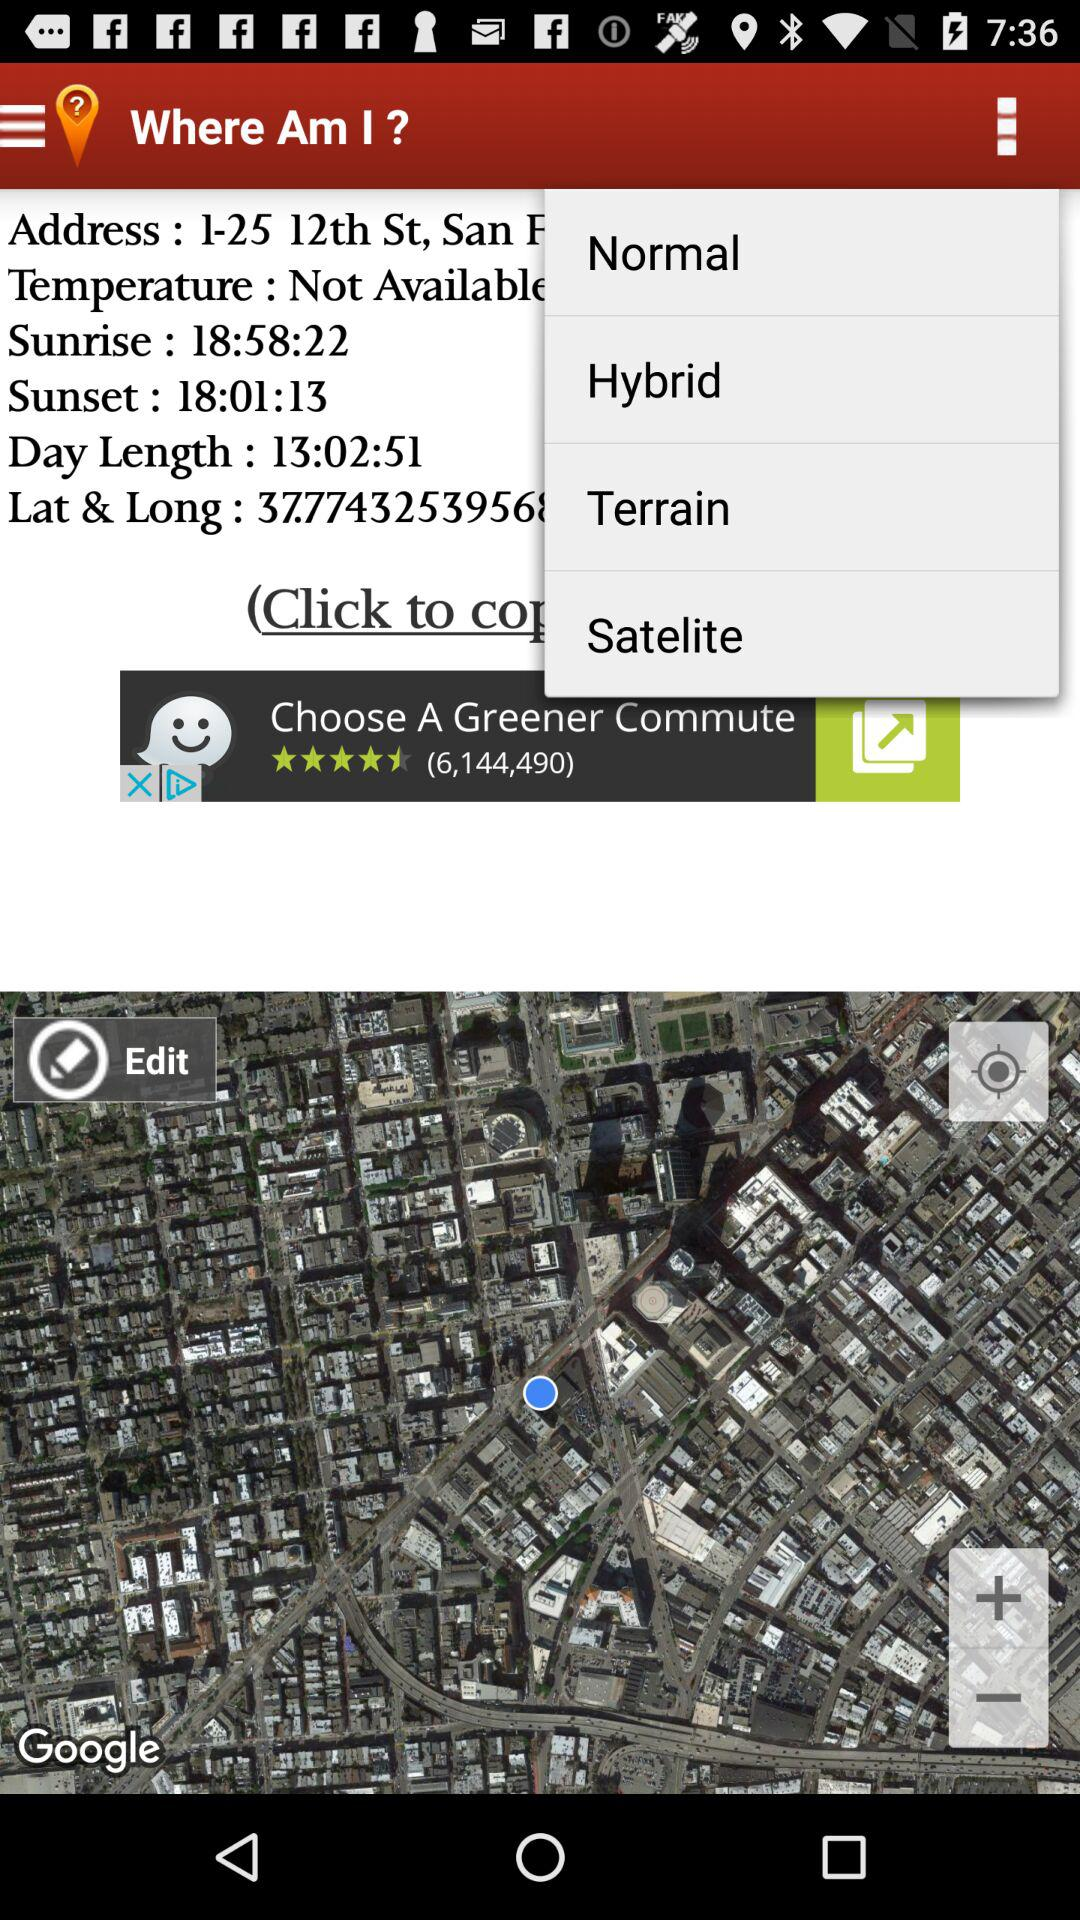At what time does the sun set? The sun sets at 6:01:13 PM. 